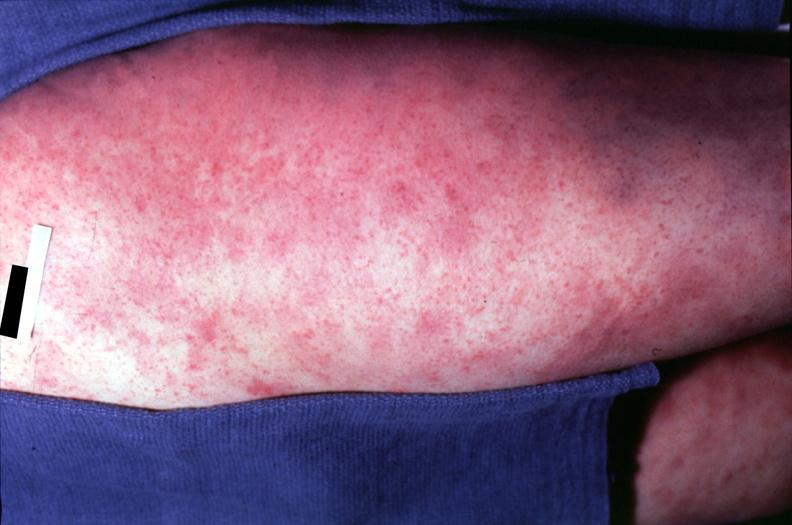where is this?
Answer the question using a single word or phrase. Skin 